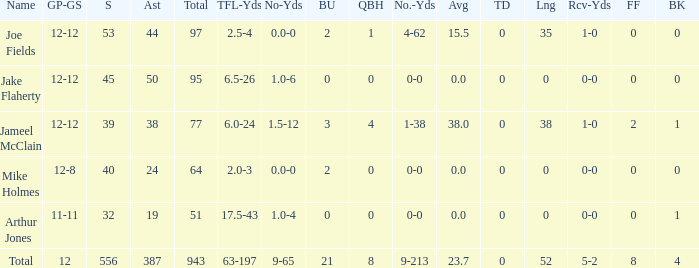How many yards for the player with tfl-yds of 2.5-4? 4-62. 